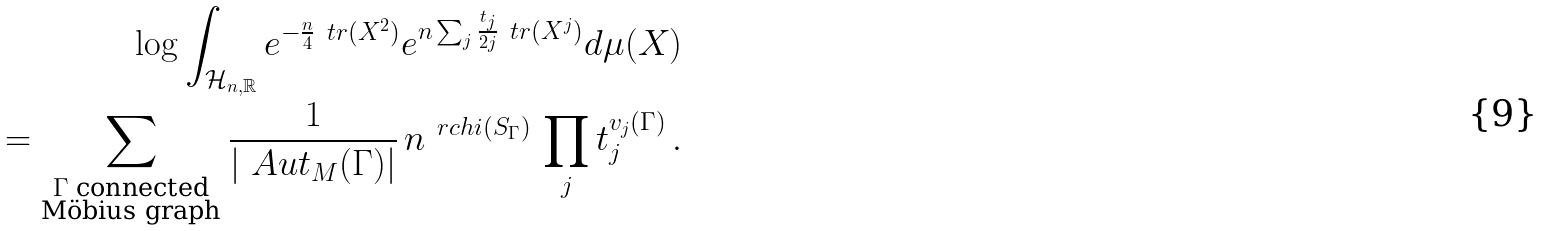<formula> <loc_0><loc_0><loc_500><loc_500>\log \int _ { \mathcal { H } _ { n , \mathbb { R } } } e ^ { - \frac { n } { 4 } \ t r ( X ^ { 2 } ) } e ^ { n \sum _ { j } \frac { t _ { j } } { 2 j } \ t r ( X ^ { j } ) } d \mu ( X ) \\ = \sum _ { \substack { \Gamma \text { connected} \\ \text {M\"obius graph} } } \frac { 1 } { | \ A u t _ { M } ( \Gamma ) | } \, n ^ { \ r c h i ( S _ { \Gamma } ) } \, \prod _ { j } t _ { j } ^ { v _ { j } ( \Gamma ) } \, .</formula> 